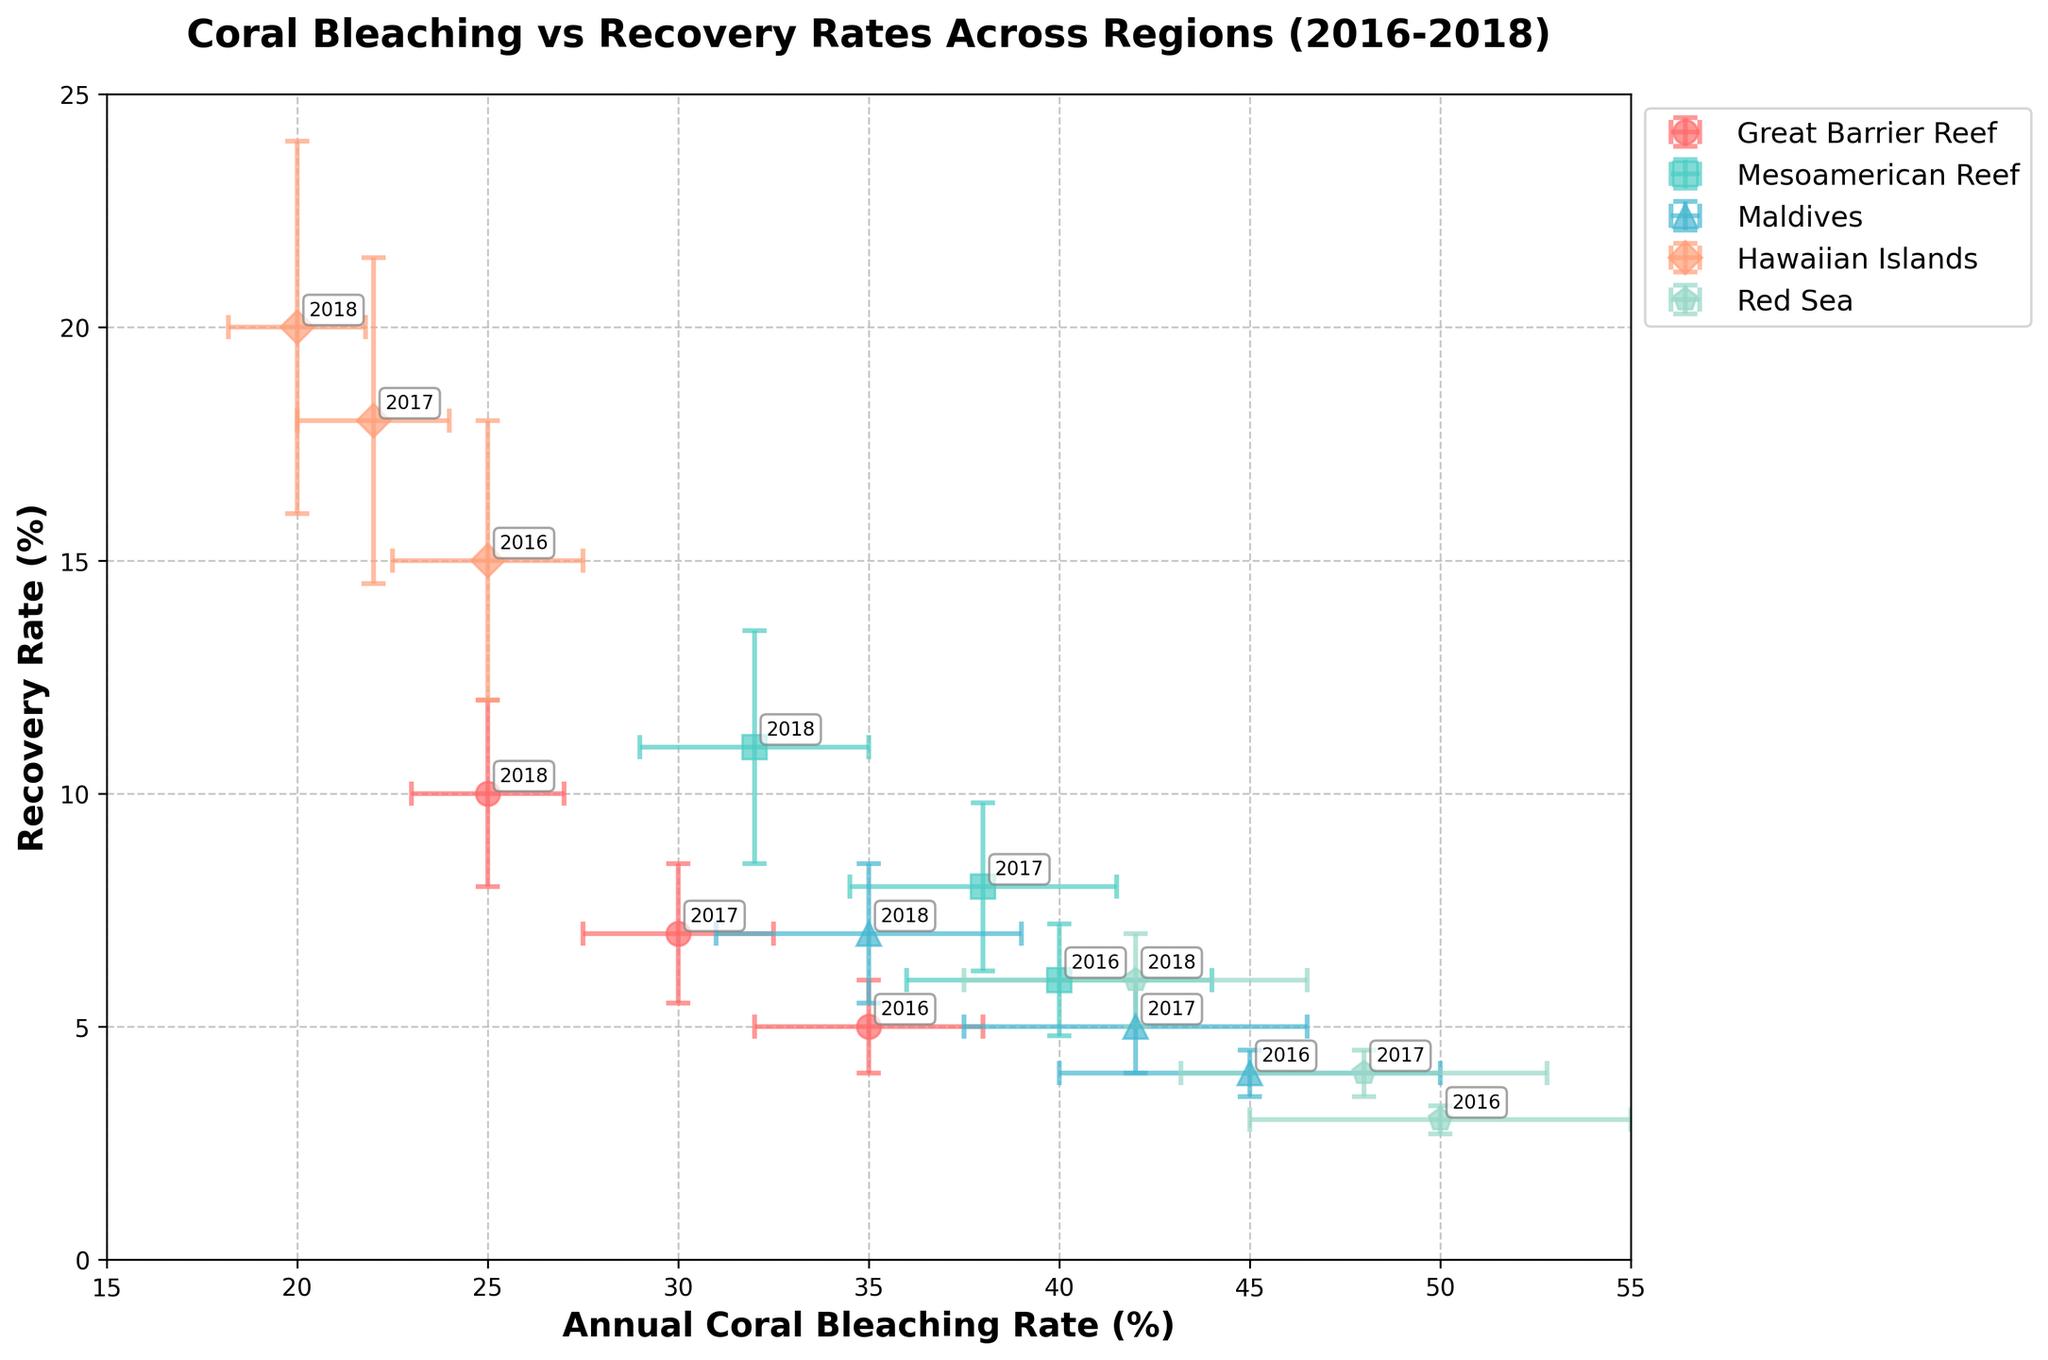What is the title of the figure? The title is the text placed at the top of the figure. It provides an overview of what the figure is about.
Answer: Coral Bleaching vs Recovery Rates Across Regions (2016-2018) What are the x and y axes labels? The x-axis and y-axis labels are situated along the horizontal and vertical axes, respectively. They describe what each axis represents.
Answer: The x-axis label is "Annual Coral Bleaching Rate (%)" and the y-axis label is "Recovery Rate (%)" Which region had the highest bleaching rate in 2016? To find this, look for the highest data point on the x-axis in 2016. Check the corresponding region.
Answer: Red Sea What trend is observed in the recovery rates for the Great Barrier Reef from 2016 to 2018? Examine the recovery rate for the given years in the Great Barrier Reef region, then observe if it's increasing, decreasing, or stable.
Answer: The recovery rate is increasing How do the error bars for bleaching rates compare between regions in 2016? Look at the error bars for bleaching rates in 2016 on the x-axis. Compare their lengths to see which are longer or shorter.
Answer: The Maldives and Red Sea have the largest error bars, while the Great Barrier Reef and Hawaiian Islands have smaller ones What is the average recovery rate in 2018 across all regions? Take the recovery rates for each region in 2018, add them, and divide by the number of regions. Calculation: (10 + 11 + 7 + 20 + 6) / 5
Answer: 10.8% For which year and region is the difference between bleaching rate and recovery rate the smallest? Calculate the difference between the bleaching rates and recovery rates for each region and year. Find the smallest difference. Detailed steps: Calculate differences for all, e.g., Great Barrier Reef 2018: 25 - 10 = 15.
Answer: Hawaiian Islands in 2018 with a difference of 0% Compare the bleaching rates of the Great Barrier Reef and Mesoamerican Reef in 2017. Which one is higher? Look at the bleaching rates marked for 2017 for both regions on the x-axis and compare the values.
Answer: Mesoamerican Reef is higher (38% vs. 30%) Which region shows the least variation in recovery rates from 2016 to 2018? Examine the recovery rate error bars for each region over the years. Identify the region with the shortest and most consistent error bars over time.
Answer: Great Barrier Reef 